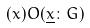Convert formula to latex. <formula><loc_0><loc_0><loc_500><loc_500>( x ) O ( \underline { x } \colon G )</formula> 